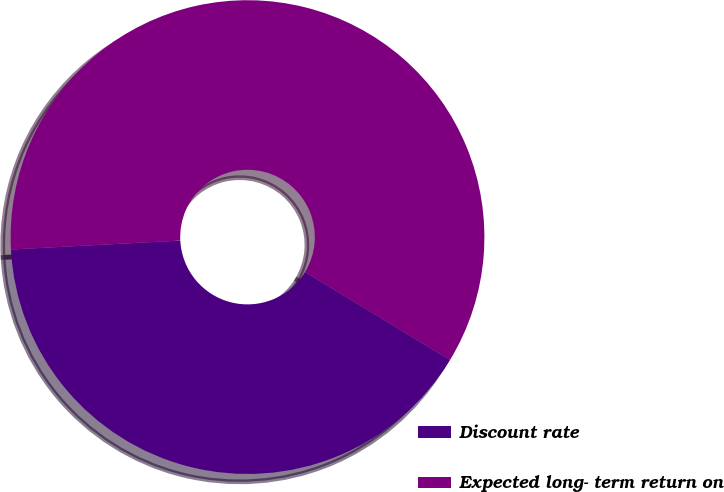Convert chart. <chart><loc_0><loc_0><loc_500><loc_500><pie_chart><fcel>Discount rate<fcel>Expected long- term return on<nl><fcel>40.48%<fcel>59.52%<nl></chart> 